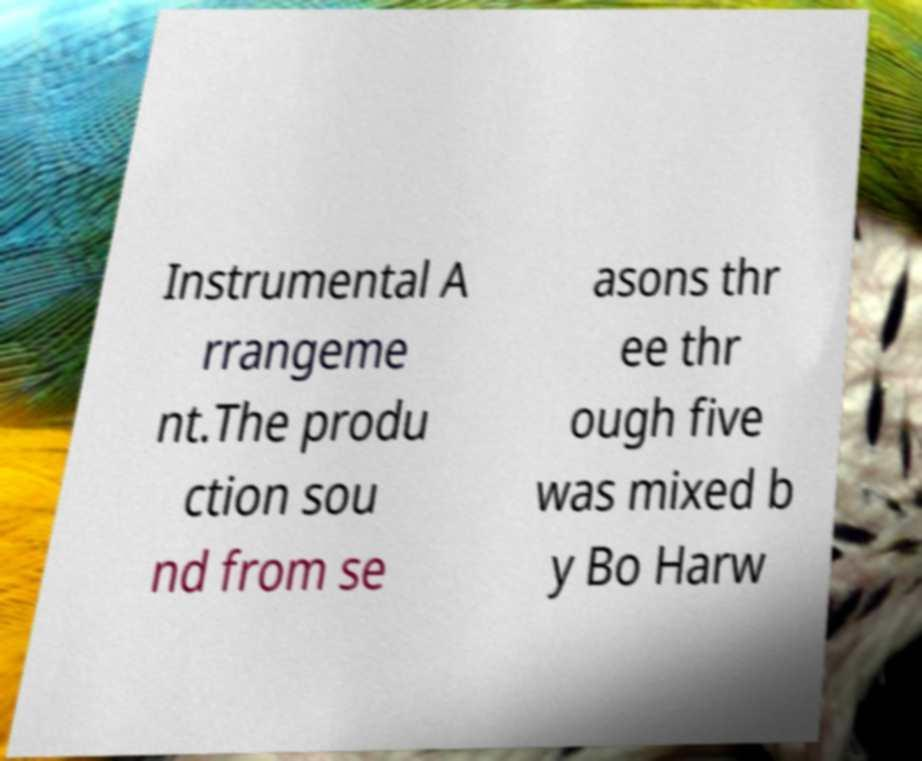Please identify and transcribe the text found in this image. Instrumental A rrangeme nt.The produ ction sou nd from se asons thr ee thr ough five was mixed b y Bo Harw 